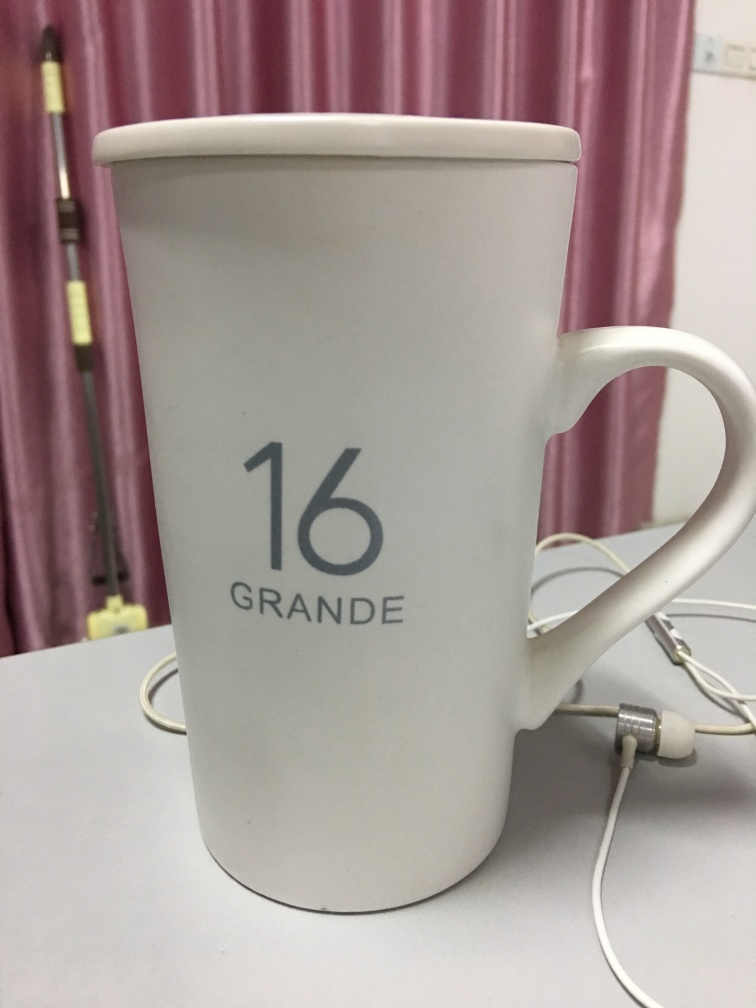Is the quality of this image relatively good?
A. Yes
B. No
Answer with the option's letter from the given choices directly.
 A. 